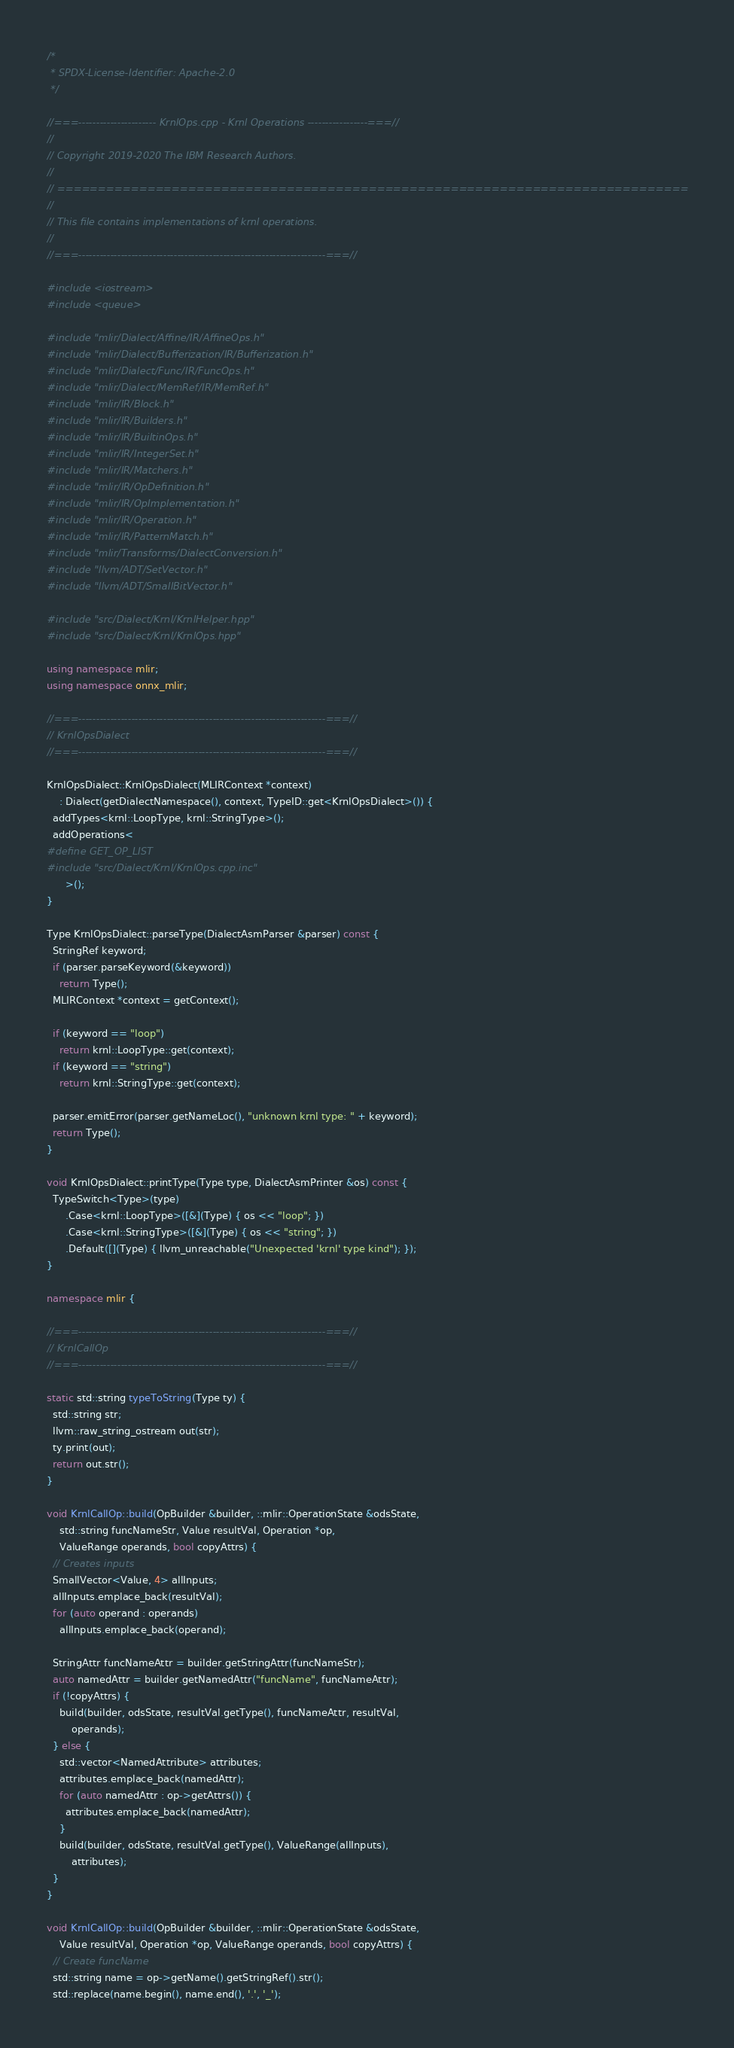<code> <loc_0><loc_0><loc_500><loc_500><_C++_>/*
 * SPDX-License-Identifier: Apache-2.0
 */

//===---------------------- KrnlOps.cpp - Krnl Operations -----------------===//
//
// Copyright 2019-2020 The IBM Research Authors.
//
// =============================================================================
//
// This file contains implementations of krnl operations.
//
//===----------------------------------------------------------------------===//

#include <iostream>
#include <queue>

#include "mlir/Dialect/Affine/IR/AffineOps.h"
#include "mlir/Dialect/Bufferization/IR/Bufferization.h"
#include "mlir/Dialect/Func/IR/FuncOps.h"
#include "mlir/Dialect/MemRef/IR/MemRef.h"
#include "mlir/IR/Block.h"
#include "mlir/IR/Builders.h"
#include "mlir/IR/BuiltinOps.h"
#include "mlir/IR/IntegerSet.h"
#include "mlir/IR/Matchers.h"
#include "mlir/IR/OpDefinition.h"
#include "mlir/IR/OpImplementation.h"
#include "mlir/IR/Operation.h"
#include "mlir/IR/PatternMatch.h"
#include "mlir/Transforms/DialectConversion.h"
#include "llvm/ADT/SetVector.h"
#include "llvm/ADT/SmallBitVector.h"

#include "src/Dialect/Krnl/KrnlHelper.hpp"
#include "src/Dialect/Krnl/KrnlOps.hpp"

using namespace mlir;
using namespace onnx_mlir;

//===----------------------------------------------------------------------===//
// KrnlOpsDialect
//===----------------------------------------------------------------------===//

KrnlOpsDialect::KrnlOpsDialect(MLIRContext *context)
    : Dialect(getDialectNamespace(), context, TypeID::get<KrnlOpsDialect>()) {
  addTypes<krnl::LoopType, krnl::StringType>();
  addOperations<
#define GET_OP_LIST
#include "src/Dialect/Krnl/KrnlOps.cpp.inc"
      >();
}

Type KrnlOpsDialect::parseType(DialectAsmParser &parser) const {
  StringRef keyword;
  if (parser.parseKeyword(&keyword))
    return Type();
  MLIRContext *context = getContext();

  if (keyword == "loop")
    return krnl::LoopType::get(context);
  if (keyword == "string")
    return krnl::StringType::get(context);

  parser.emitError(parser.getNameLoc(), "unknown krnl type: " + keyword);
  return Type();
}

void KrnlOpsDialect::printType(Type type, DialectAsmPrinter &os) const {
  TypeSwitch<Type>(type)
      .Case<krnl::LoopType>([&](Type) { os << "loop"; })
      .Case<krnl::StringType>([&](Type) { os << "string"; })
      .Default([](Type) { llvm_unreachable("Unexpected 'krnl' type kind"); });
}

namespace mlir {

//===----------------------------------------------------------------------===//
// KrnlCallOp
//===----------------------------------------------------------------------===//

static std::string typeToString(Type ty) {
  std::string str;
  llvm::raw_string_ostream out(str);
  ty.print(out);
  return out.str();
}

void KrnlCallOp::build(OpBuilder &builder, ::mlir::OperationState &odsState,
    std::string funcNameStr, Value resultVal, Operation *op,
    ValueRange operands, bool copyAttrs) {
  // Creates inputs
  SmallVector<Value, 4> allInputs;
  allInputs.emplace_back(resultVal);
  for (auto operand : operands)
    allInputs.emplace_back(operand);

  StringAttr funcNameAttr = builder.getStringAttr(funcNameStr);
  auto namedAttr = builder.getNamedAttr("funcName", funcNameAttr);
  if (!copyAttrs) {
    build(builder, odsState, resultVal.getType(), funcNameAttr, resultVal,
        operands);
  } else {
    std::vector<NamedAttribute> attributes;
    attributes.emplace_back(namedAttr);
    for (auto namedAttr : op->getAttrs()) {
      attributes.emplace_back(namedAttr);
    }
    build(builder, odsState, resultVal.getType(), ValueRange(allInputs),
        attributes);
  }
}

void KrnlCallOp::build(OpBuilder &builder, ::mlir::OperationState &odsState,
    Value resultVal, Operation *op, ValueRange operands, bool copyAttrs) {
  // Create funcName
  std::string name = op->getName().getStringRef().str();
  std::replace(name.begin(), name.end(), '.', '_');</code> 